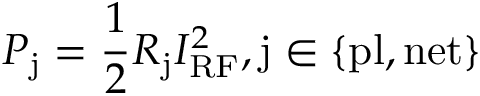<formula> <loc_0><loc_0><loc_500><loc_500>P _ { j } = \frac { 1 } { 2 } R _ { j } I _ { R F } ^ { 2 } , j \in \{ p l , n e t \}</formula> 